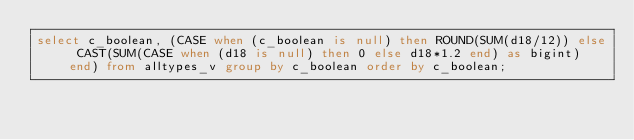<code> <loc_0><loc_0><loc_500><loc_500><_SQL_>select c_boolean, (CASE when (c_boolean is null) then ROUND(SUM(d18/12)) else CAST(SUM(CASE when (d18 is null) then 0 else d18*1.2 end) as bigint)  end) from alltypes_v group by c_boolean order by c_boolean;
</code> 